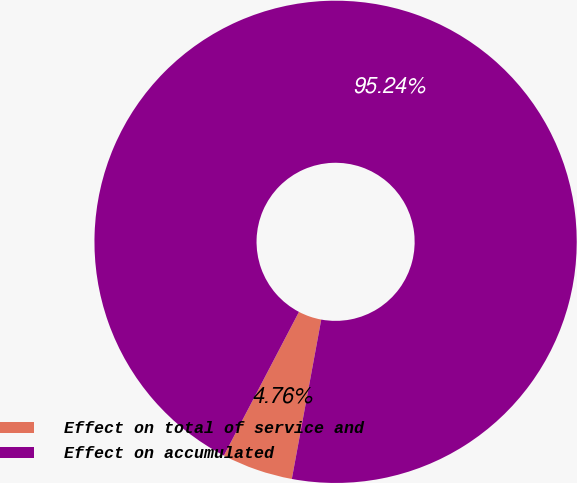Convert chart. <chart><loc_0><loc_0><loc_500><loc_500><pie_chart><fcel>Effect on total of service and<fcel>Effect on accumulated<nl><fcel>4.76%<fcel>95.24%<nl></chart> 